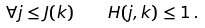Convert formula to latex. <formula><loc_0><loc_0><loc_500><loc_500>\forall j \leq J ( k ) \quad H ( j , k ) \leq 1 \, .</formula> 